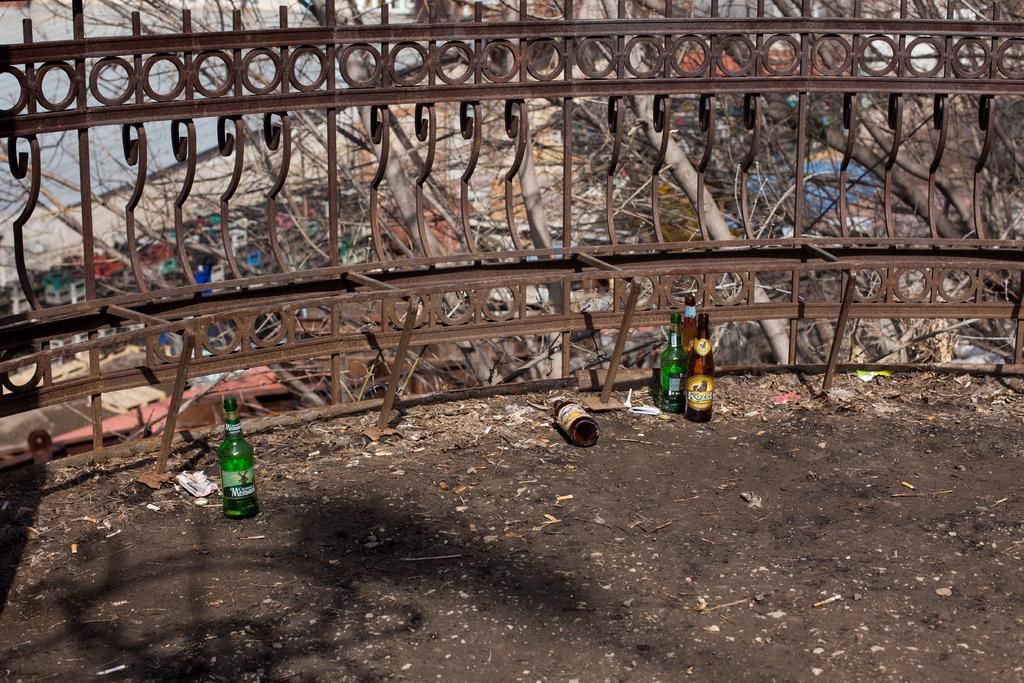What color is the ground in the image? The ground in the image is black. What colors are the bottles in the image? The bottles in the image are green and brown. What color is the grill in the image? The grill in the image is brown. What can be seen in the background of the image? There are trees visible in the background of the image. What type of nose can be seen on the grill in the image? There is no nose present on the grill in the image; it is a grilling appliance. What hope does the image convey? The image does not convey any specific hope or emotion; it is a still image of a grill, bottles, and trees. 